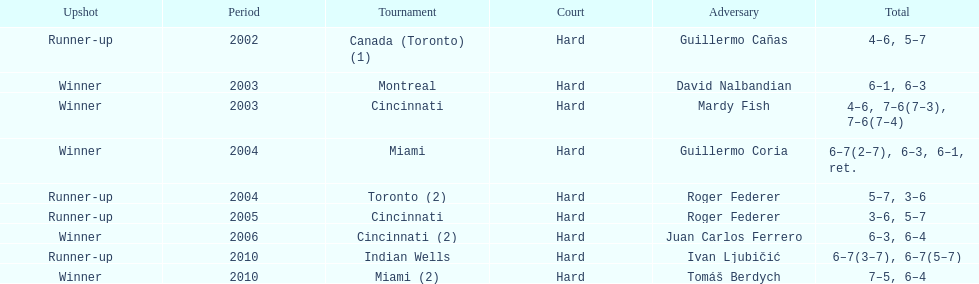How many times were roddick's opponents not from the usa? 8. 